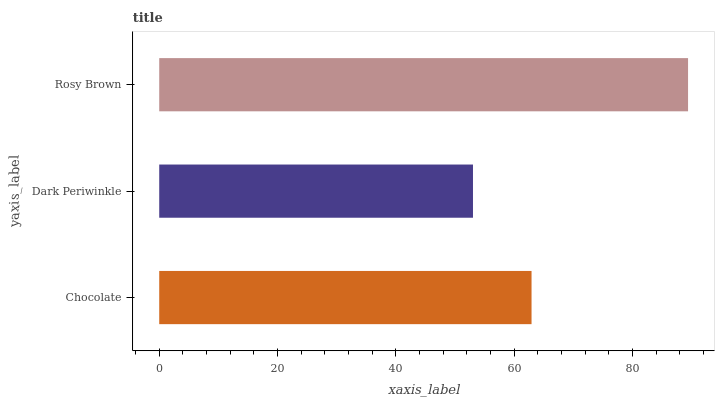Is Dark Periwinkle the minimum?
Answer yes or no. Yes. Is Rosy Brown the maximum?
Answer yes or no. Yes. Is Rosy Brown the minimum?
Answer yes or no. No. Is Dark Periwinkle the maximum?
Answer yes or no. No. Is Rosy Brown greater than Dark Periwinkle?
Answer yes or no. Yes. Is Dark Periwinkle less than Rosy Brown?
Answer yes or no. Yes. Is Dark Periwinkle greater than Rosy Brown?
Answer yes or no. No. Is Rosy Brown less than Dark Periwinkle?
Answer yes or no. No. Is Chocolate the high median?
Answer yes or no. Yes. Is Chocolate the low median?
Answer yes or no. Yes. Is Dark Periwinkle the high median?
Answer yes or no. No. Is Rosy Brown the low median?
Answer yes or no. No. 